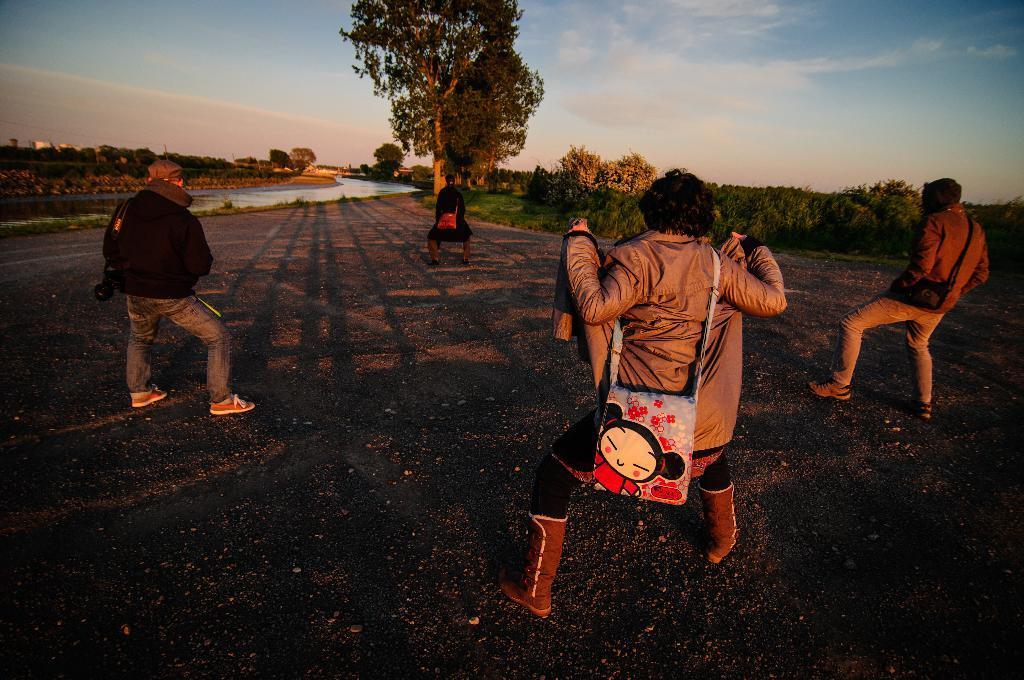In one or two sentences, can you explain what this image depicts? In this image, we can see four persons wearing clothes and dancing on the ground. There are some plants on the right side of the image. There is a canal on the left side of the image. There is a tree and sky at the top of the image. 